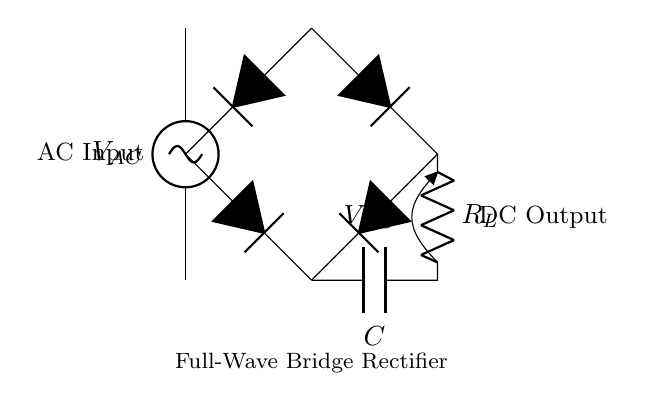What type of rectifier is shown? The circuit is labeled as a "Full-Wave Bridge Rectifier," indicating that it uses a bridge configuration to convert AC to DC.
Answer: Full-Wave Bridge Rectifier How many diodes are used in this circuit? The diagram shows four diodes arranged in a bridge configuration, essential for full-wave rectification.
Answer: Four What is the function of the load resistor in this circuit? The load resistor, labeled as R_L, converts the rectified AC into DC power for the connected load, allowing devices to operate.
Answer: To convert AC to DC What does the capacitor do in this configuration? The capacitor, labeled C, smooths out the output voltage by filtering the ripples in the rectified DC, providing a more stable voltage.
Answer: Smooth the output voltage What is the expected output voltage type? The output voltage, indicated as V_DC, is the DC voltage resulting from the rectification process, converting the AC input into a usable form for electronic devices.
Answer: DC Explain why this is considered a full-wave rectifier. The circuit allows both halves of the AC waveform to be utilized for rectification, using diodes to conduct during both positive and negative cycles, effectively doubling the frequency of the output.
Answer: Utilizes both halves of AC 